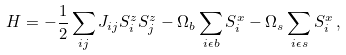Convert formula to latex. <formula><loc_0><loc_0><loc_500><loc_500>H = - \frac { 1 } { 2 } \sum _ { i j } J _ { i j } S ^ { z } _ { i } S ^ { z } _ { j } - \Omega _ { b } \sum _ { i \epsilon b } S ^ { x } _ { i } - \Omega _ { s } \sum _ { i \epsilon s } S ^ { x } _ { i } \, ,</formula> 